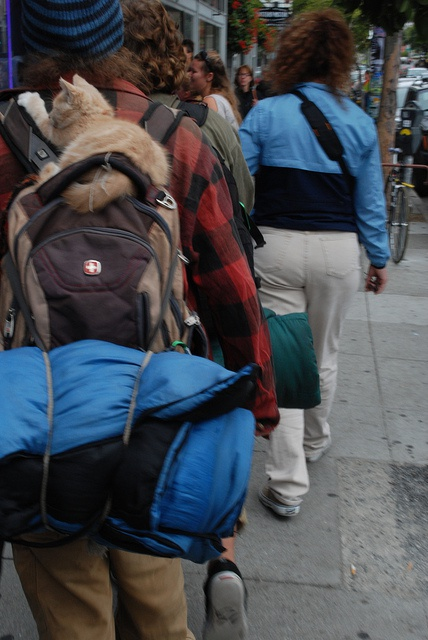Describe the objects in this image and their specific colors. I can see people in gray, black, blue, and maroon tones, people in gray, black, and darkgray tones, backpack in gray and black tones, cat in gray, darkgray, and tan tones, and people in gray, black, maroon, and brown tones in this image. 